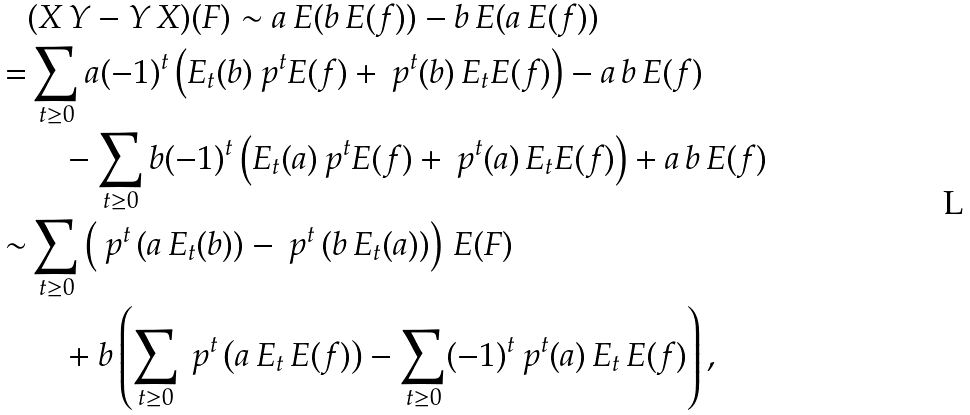Convert formula to latex. <formula><loc_0><loc_0><loc_500><loc_500>& ( X \, Y - Y \, X ) ( F ) \sim a \, E ( b \, E ( f ) ) - b \, E ( a \, E ( f ) ) \\ = & \sum _ { t \geq 0 } a ( - 1 ) ^ { t } \left ( E _ { t } ( b ) \ p ^ { t } E ( f ) + \ p ^ { t } ( b ) \, E _ { t } E ( f ) \right ) - a \, b \, E ( f ) \\ & \quad - \sum _ { t \geq 0 } b ( - 1 ) ^ { t } \left ( E _ { t } ( a ) \ p ^ { t } E ( f ) + \ p ^ { t } ( a ) \, E _ { t } E ( f ) \right ) + a \, b \, E ( f ) \\ \sim & \sum _ { t \geq 0 } \left ( \ p ^ { t } \left ( a \, E _ { t } ( b ) \right ) - \ p ^ { t } \left ( b \, E _ { t } ( a ) \right ) \right ) \, E ( F ) \\ & \quad + b \left ( \sum _ { t \geq 0 } \ p ^ { t } \left ( a \, E _ { t } \, E ( f ) \right ) - \sum _ { t \geq 0 } ( - 1 ) ^ { t } \ p ^ { t } ( a ) \, E _ { t } \, E ( f ) \right ) ,</formula> 